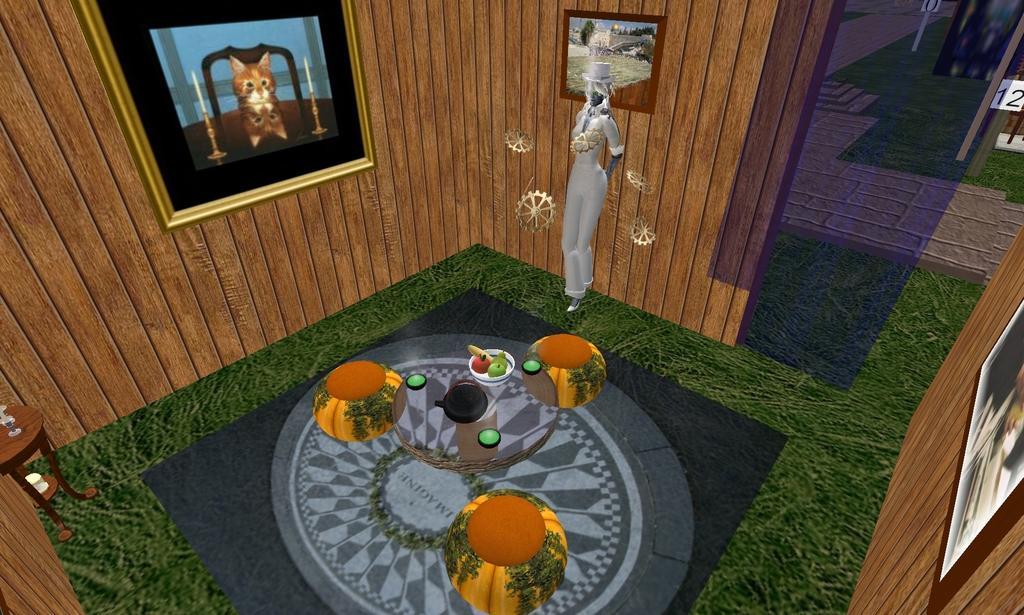Please provide a concise description of this image. In this picture I can see a graphical image and I can see few photo frames and a table on the left side and looks like dining table in the middle and I can see a bowl with fruits on the table and it looks like a statue. 